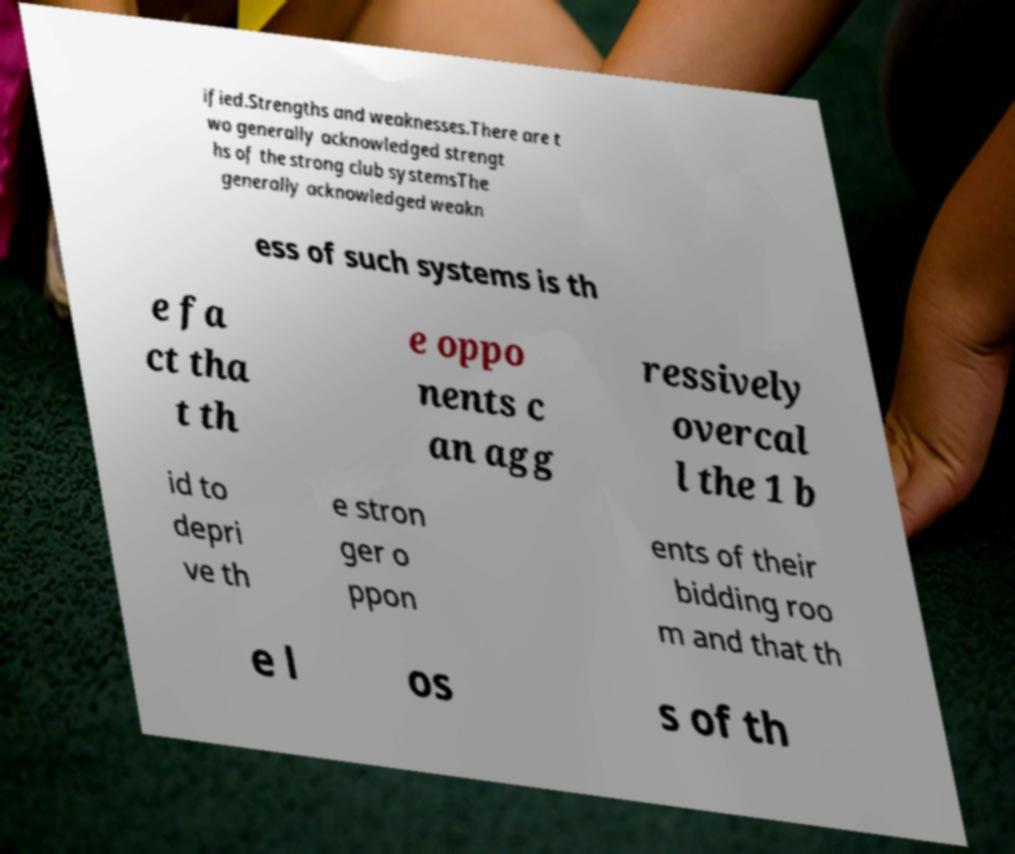Please read and relay the text visible in this image. What does it say? ified.Strengths and weaknesses.There are t wo generally acknowledged strengt hs of the strong club systemsThe generally acknowledged weakn ess of such systems is th e fa ct tha t th e oppo nents c an agg ressively overcal l the 1 b id to depri ve th e stron ger o ppon ents of their bidding roo m and that th e l os s of th 